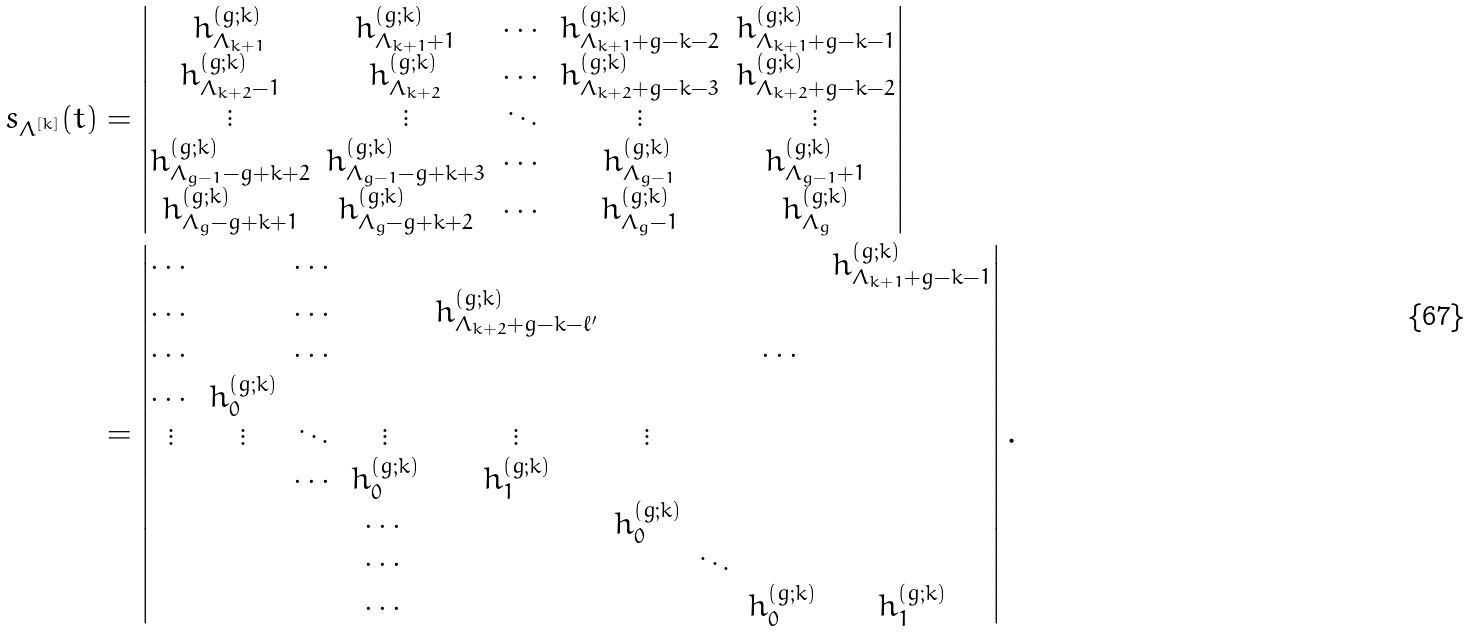<formula> <loc_0><loc_0><loc_500><loc_500>s _ { \Lambda ^ { [ k ] } } ( t ) & = \left | \begin{matrix} h ^ { ( g ; k ) } _ { \Lambda _ { k + 1 } } & h ^ { ( g ; k ) } _ { \Lambda _ { k + 1 } + 1 } & \cdots & h ^ { ( g ; k ) } _ { \Lambda _ { k + 1 } + g - k - 2 } & h ^ { ( g ; k ) } _ { \Lambda _ { k + 1 } + g - k - 1 } \\ h ^ { ( g ; k ) } _ { \Lambda _ { k + 2 } - 1 } & h ^ { ( g ; k ) } _ { \Lambda _ { k + 2 } } & \cdots & h ^ { ( g ; k ) } _ { \Lambda _ { k + 2 } + g - k - 3 } & h ^ { ( g ; k ) } _ { \Lambda _ { k + 2 } + g - k - 2 } \\ \vdots & \vdots & \ddots & \vdots & \vdots \\ h ^ { ( g ; k ) } _ { \Lambda _ { g - 1 } - g + k + 2 } & h ^ { ( g ; k ) } _ { \Lambda _ { g - 1 } - g + k + 3 } & \cdots & h ^ { ( g ; k ) } _ { \Lambda _ { g - 1 } } & h ^ { ( g ; k ) } _ { \Lambda _ { g - 1 } + 1 } \\ h ^ { ( g ; k ) } _ { \Lambda _ { g } - g + k + 1 } & h ^ { ( g ; k ) } _ { \Lambda _ { g } - g + k + 2 } & \cdots & h ^ { ( g ; k ) } _ { \Lambda _ { g } - 1 } & h ^ { ( g ; k ) } _ { \Lambda _ { g } } \\ \end{matrix} \right | \\ & = \left | \begin{matrix} \cdots & & \cdots & & & & & & h ^ { ( g ; k ) } _ { \Lambda _ { k + 1 } + g - k - 1 } \\ \cdots & & \cdots & & h ^ { ( g ; k ) } _ { \Lambda _ { k + 2 } + g - k - \ell ^ { \prime } } & & \\ \cdots & & \cdots & & & & & \cdots & \\ \cdots & h ^ { ( g ; k ) } _ { 0 } & & & & & & & \\ \vdots & \vdots & \ddots & \vdots & \vdots & \vdots \\ & & \cdots & h ^ { ( g ; k ) } _ { 0 } & h ^ { ( g ; k ) } _ { 1 } & & & \\ & & & \cdots & & h ^ { ( g ; k ) } _ { 0 } & & & \\ & & & \cdots & & & \ddots & & \\ & & & \cdots & & & & h ^ { ( g ; k ) } _ { 0 } & h ^ { ( g ; k ) } _ { 1 } \\ \end{matrix} \right | .</formula> 